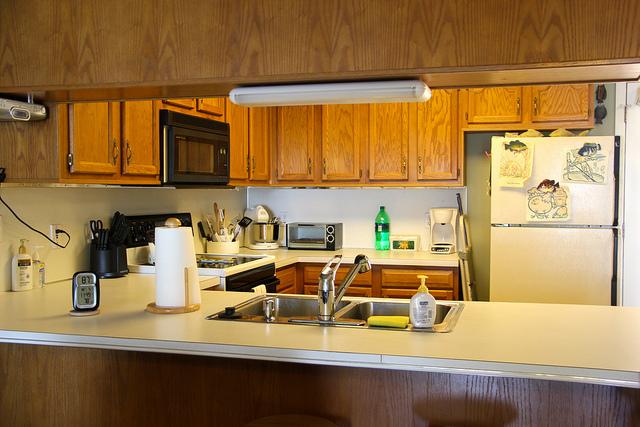What color is the fridge?
Be succinct. White. Is there a fridge in the picture?
Answer briefly. Yes. What color is the faucet?
Be succinct. Silver. 